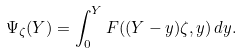<formula> <loc_0><loc_0><loc_500><loc_500>\Psi _ { \zeta } ( Y ) = \int _ { 0 } ^ { Y } F ( ( Y - y ) \zeta , y ) \, d y .</formula> 